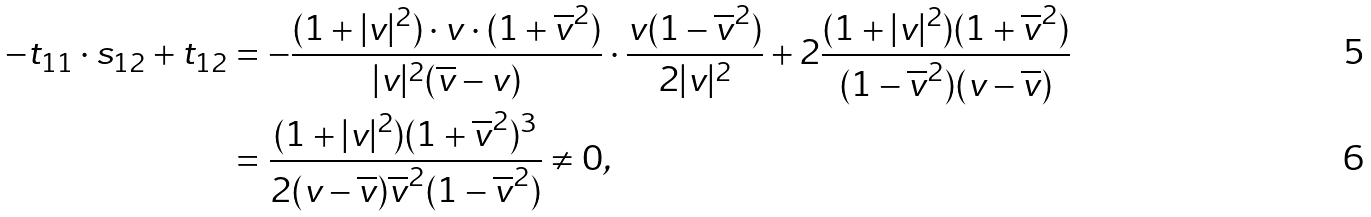Convert formula to latex. <formula><loc_0><loc_0><loc_500><loc_500>- t _ { 1 1 } \cdot s _ { 1 2 } + t _ { 1 2 } & = - \frac { ( 1 + | v | ^ { 2 } ) \cdot v \cdot ( 1 + \overline { v } ^ { 2 } ) } { | v | ^ { 2 } ( \overline { v } - v ) } \cdot \frac { v ( 1 - \overline { v } ^ { 2 } ) } { 2 | v | ^ { 2 } } + { 2 } \frac { ( 1 + | v | ^ { 2 } ) ( 1 + \overline { v } ^ { 2 } ) } { ( 1 - \overline { v } ^ { 2 } ) ( v - \overline { v } ) } \\ & = \frac { ( 1 + | v | ^ { 2 } ) ( 1 + \overline { v } ^ { 2 } ) ^ { 3 } } { 2 ( v - \overline { v } ) \overline { v } ^ { 2 } ( 1 - \overline { v } ^ { 2 } ) } \ne 0 ,</formula> 